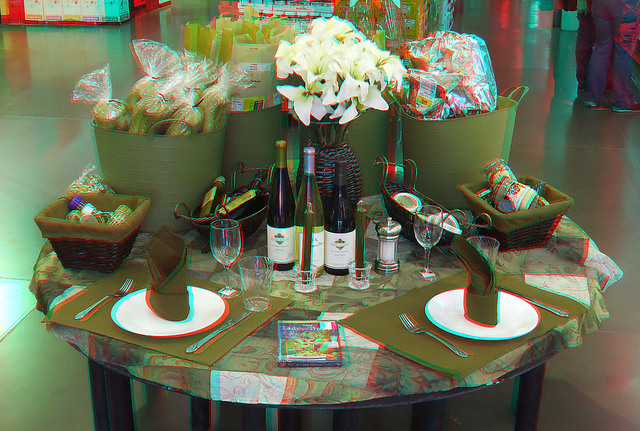<image>What are the primary colors appearing in the picture? I don't know what the primary colors in the picture are. The given colors are red, green, white, brown, yellow and blue, but the image is not provided. What are the primary colors appearing in the picture? It is ambiguous what the primary colors appearing in the picture are. It can be seen green, red, yellow, blue, and white. 